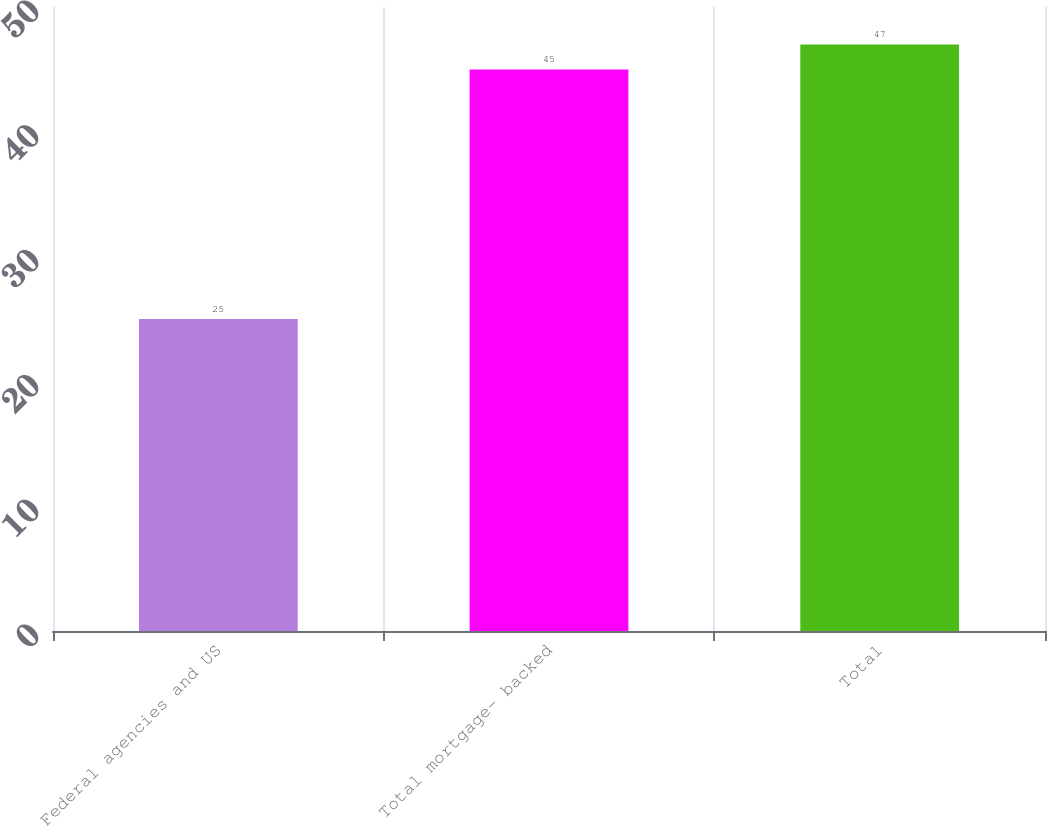Convert chart. <chart><loc_0><loc_0><loc_500><loc_500><bar_chart><fcel>Federal agencies and US<fcel>Total mortgage- backed<fcel>Total<nl><fcel>25<fcel>45<fcel>47<nl></chart> 